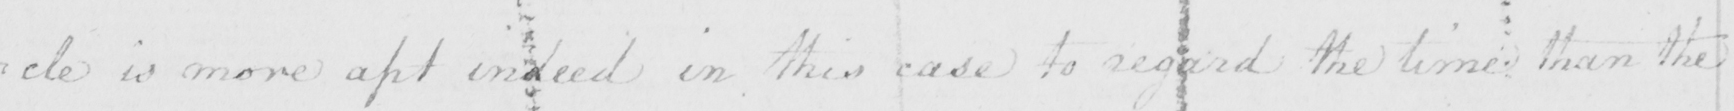Can you tell me what this handwritten text says? : cle is more apt indeed in this case to regard the time than the 